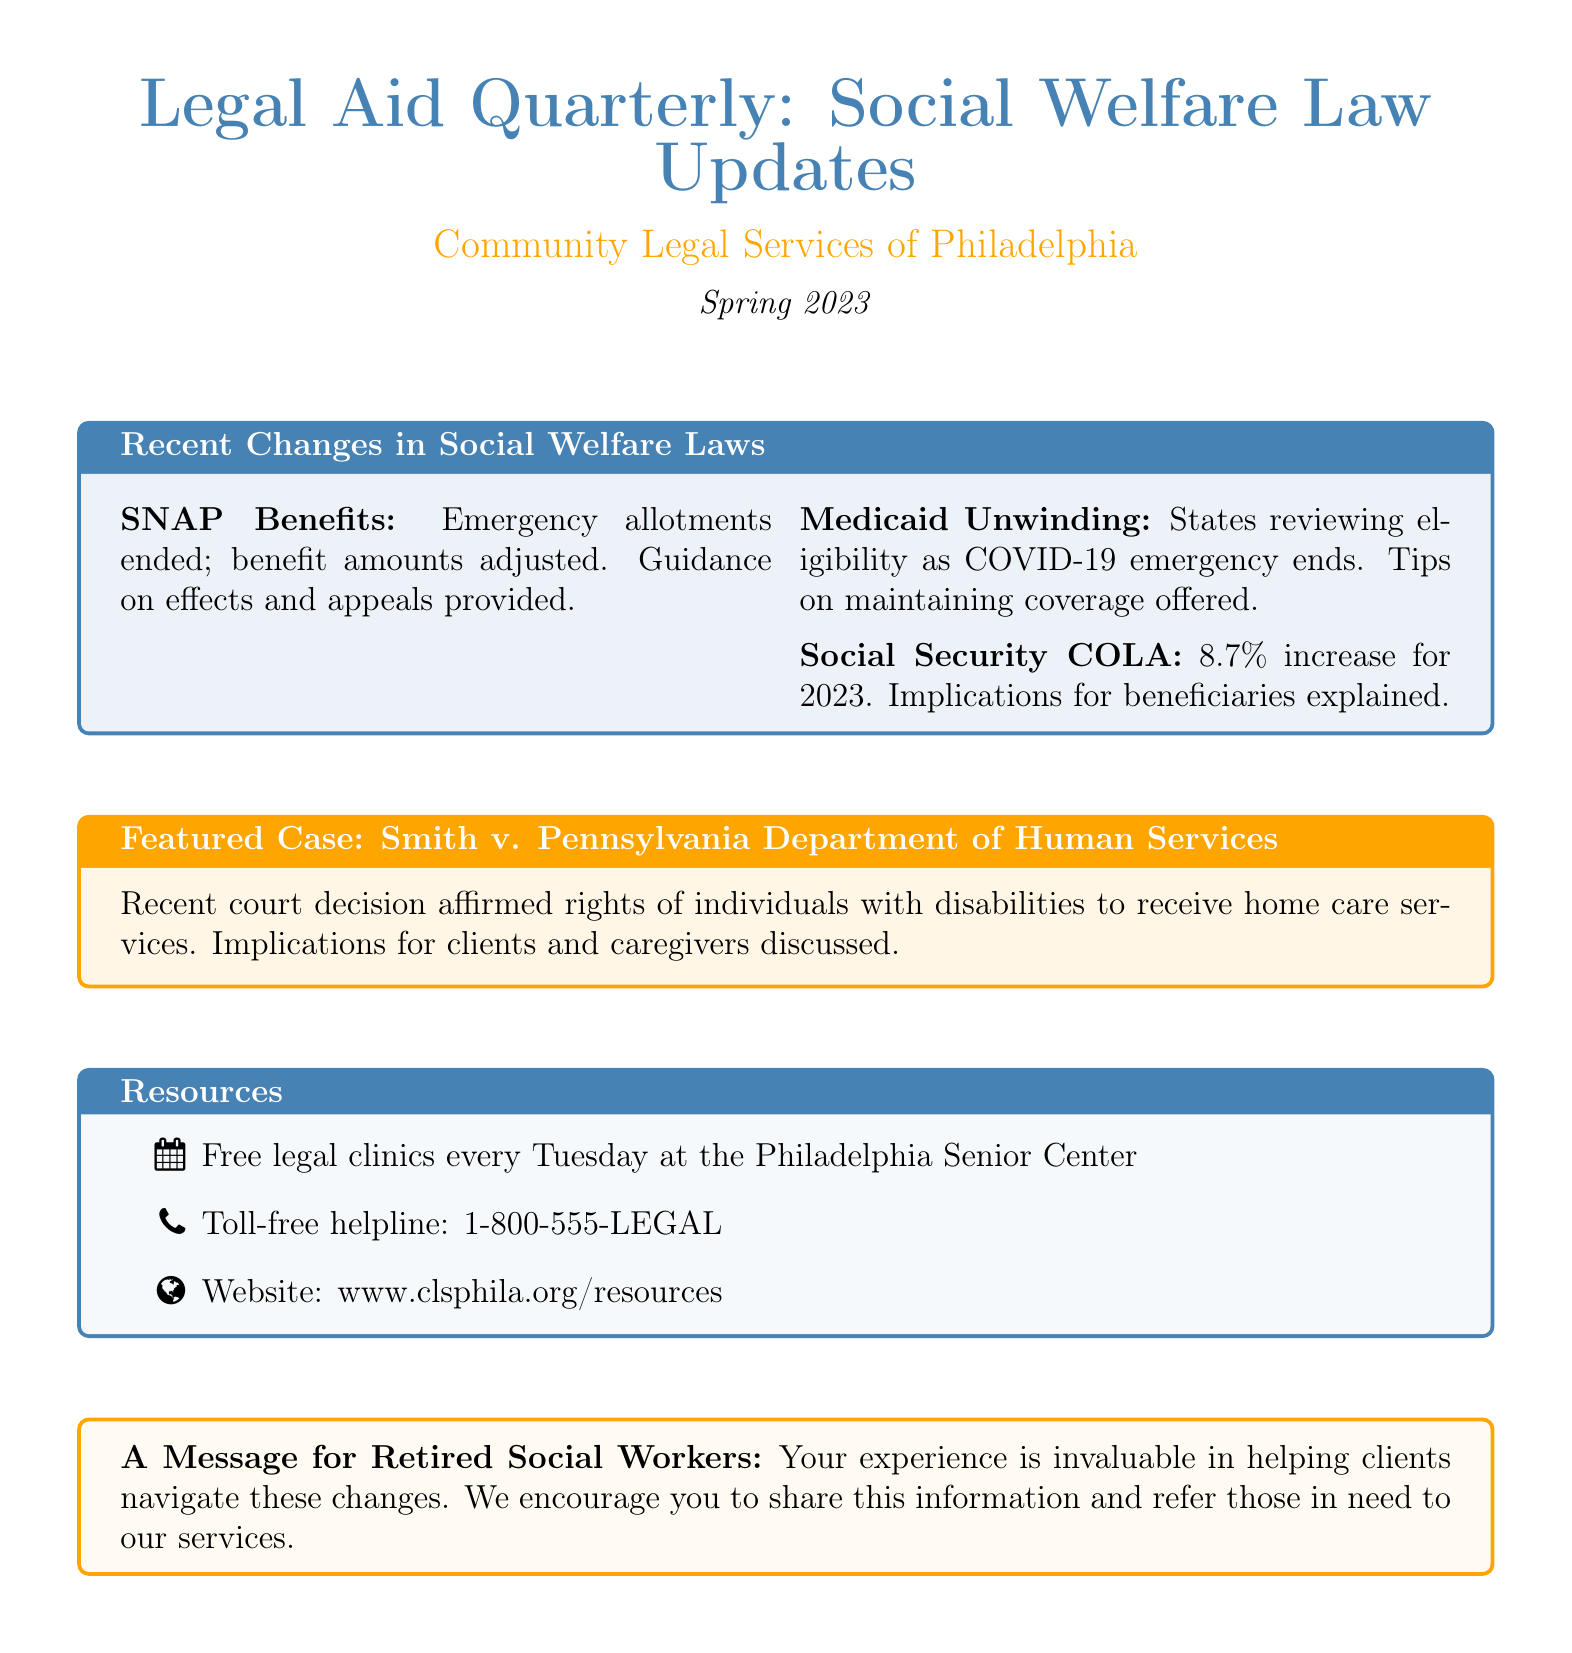What is the title of the newsletter? The title of the newsletter is stated prominently at the beginning of the document.
Answer: Legal Aid Quarterly: Social Welfare Law Updates Who is the organization behind the newsletter? The organization name is mentioned under the title in the document.
Answer: Community Legal Services of Philadelphia What is the issue date of the newsletter? The issue date is also mentioned close to the title and organization name.
Answer: Spring 2023 What percentage increase was given for Social Security benefits? The document specifies the cost-of-living adjustment percentage for Social Security benefits.
Answer: 8.7% When do the free legal clinics occur? The schedule for legal clinics is outlined in the resources section of the document.
Answer: Every Tuesday What case is featured in this newsletter? The featured case is specifically highlighted in the newsletter's content.
Answer: Smith v. Pennsylvania Department of Human Services What are recipients advised to do regarding SNAP changes? Guidance for SNAP recipients is provided for dealing with recent changes in their benefits.
Answer: Appeal decisions What does the newsletter encourage retired social workers to do? The closing message addresses the involvement of retired social workers, suggesting a specific action.
Answer: Share this information 